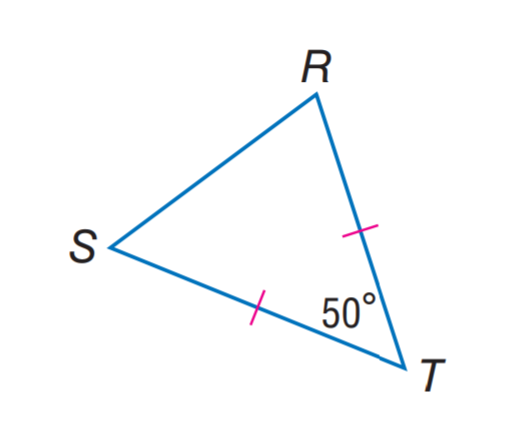Question: Find m \angle S R T.
Choices:
A. 50
B. 55
C. 60
D. 65
Answer with the letter. Answer: D 